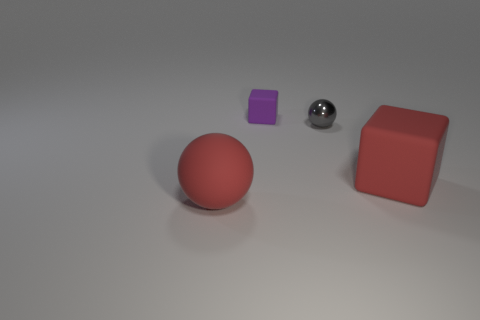What materials do the objects in the image seem to be made of? The objects appear to have different materials. The red sphere and purple cube seem to have a matte rubber-like finish, while the gray sphere looks metallic with a shiny surface, and the red cube appears to be also like rubber but with a slightly rough texture. 